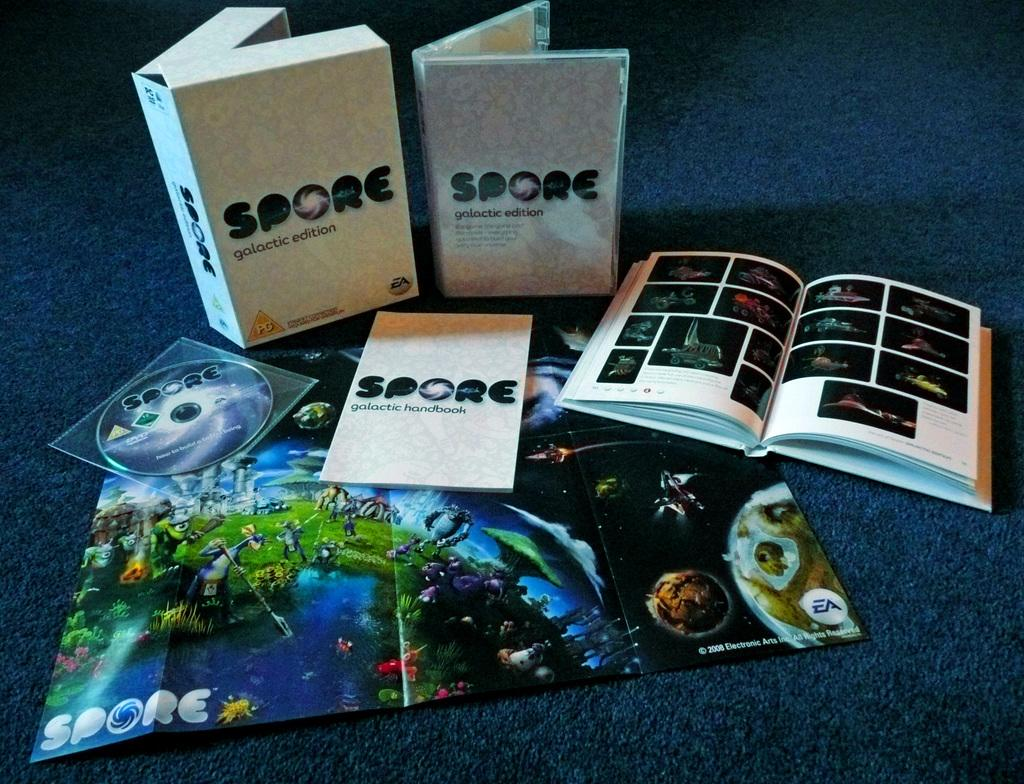<image>
Present a compact description of the photo's key features. a box that says 'spore galactic edition' on it 